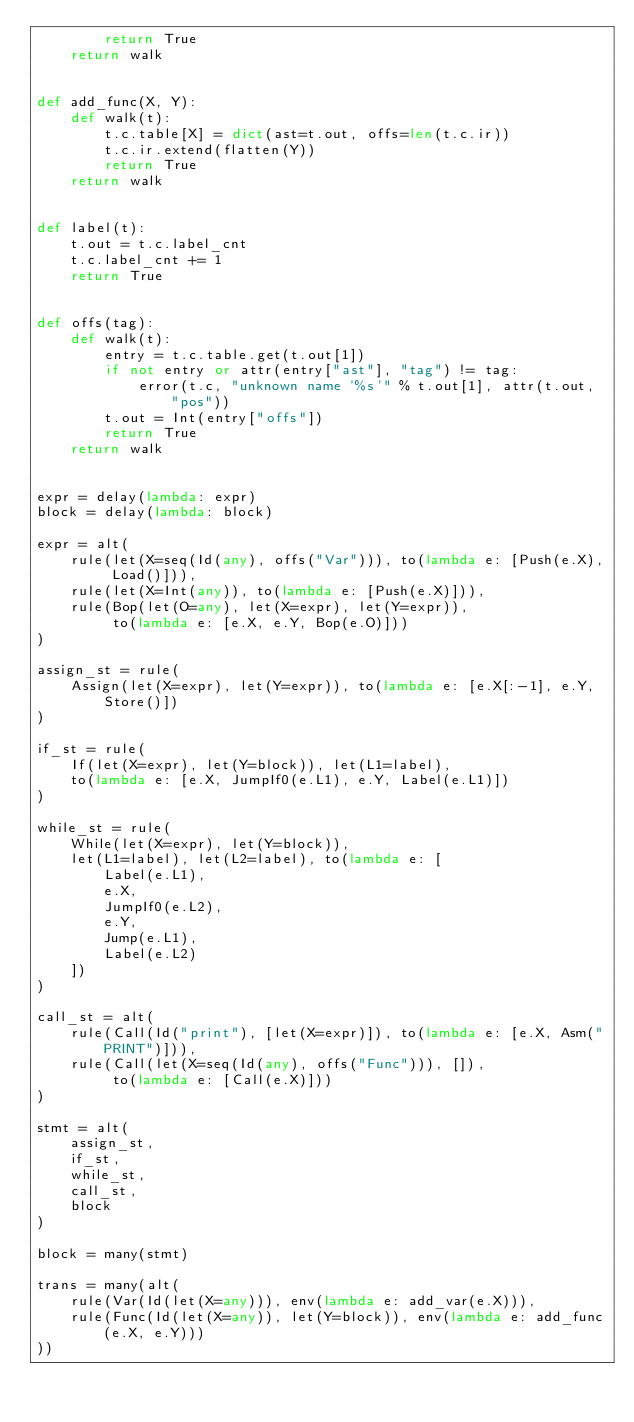<code> <loc_0><loc_0><loc_500><loc_500><_Python_>        return True
    return walk


def add_func(X, Y):
    def walk(t):
        t.c.table[X] = dict(ast=t.out, offs=len(t.c.ir))
        t.c.ir.extend(flatten(Y))
        return True
    return walk


def label(t):
    t.out = t.c.label_cnt
    t.c.label_cnt += 1
    return True


def offs(tag):
    def walk(t):
        entry = t.c.table.get(t.out[1])
        if not entry or attr(entry["ast"], "tag") != tag:
            error(t.c, "unknown name '%s'" % t.out[1], attr(t.out, "pos"))
        t.out = Int(entry["offs"])
        return True
    return walk


expr = delay(lambda: expr)
block = delay(lambda: block)

expr = alt(
    rule(let(X=seq(Id(any), offs("Var"))), to(lambda e: [Push(e.X), Load()])),
    rule(let(X=Int(any)), to(lambda e: [Push(e.X)])),
    rule(Bop(let(O=any), let(X=expr), let(Y=expr)),
         to(lambda e: [e.X, e.Y, Bop(e.O)]))
)

assign_st = rule(
    Assign(let(X=expr), let(Y=expr)), to(lambda e: [e.X[:-1], e.Y, Store()])
)

if_st = rule(
    If(let(X=expr), let(Y=block)), let(L1=label),
    to(lambda e: [e.X, JumpIf0(e.L1), e.Y, Label(e.L1)])
)

while_st = rule(
    While(let(X=expr), let(Y=block)),
    let(L1=label), let(L2=label), to(lambda e: [
        Label(e.L1),
        e.X,
        JumpIf0(e.L2),
        e.Y,
        Jump(e.L1),
        Label(e.L2)
    ])
)

call_st = alt(
    rule(Call(Id("print"), [let(X=expr)]), to(lambda e: [e.X, Asm("PRINT")])),
    rule(Call(let(X=seq(Id(any), offs("Func"))), []),
         to(lambda e: [Call(e.X)]))
)

stmt = alt(
    assign_st,
    if_st,
    while_st,
    call_st,
    block
)

block = many(stmt)

trans = many(alt(
    rule(Var(Id(let(X=any))), env(lambda e: add_var(e.X))),
    rule(Func(Id(let(X=any)), let(Y=block)), env(lambda e: add_func(e.X, e.Y)))
))
</code> 